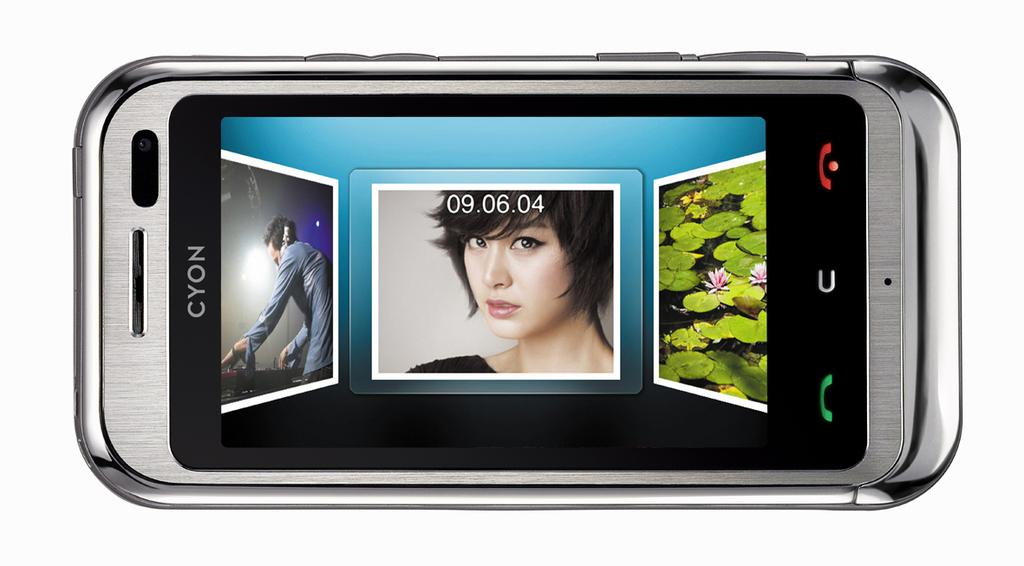What is the main subject in the center of the image? There is a mobile phone in the center of the image. What can be seen on the mobile phone screen? There are persons visible on the mobile phone screen. What type of vegetation is present in the image? Leaves and flowers are present in the image. Can you describe the toes of the persons visible on the mobile phone screen? There is no information about the toes of the persons visible on the mobile phone screen, as the image only shows the mobile phone itself and not the persons' feet. 